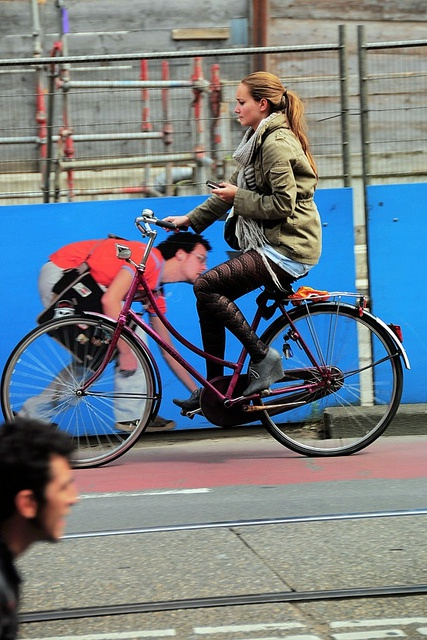Describe the objects in this image and their specific colors. I can see bicycle in gray, black, and darkgray tones, people in gray, black, tan, and darkgray tones, people in gray, black, salmon, brown, and darkgray tones, people in gray, black, brown, maroon, and salmon tones, and people in gray, black, darkgray, and brown tones in this image. 